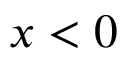Convert formula to latex. <formula><loc_0><loc_0><loc_500><loc_500>x < 0</formula> 